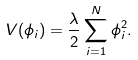<formula> <loc_0><loc_0><loc_500><loc_500>V ( \phi _ { i } ) = \frac { \lambda } { 2 } \sum _ { i = 1 } ^ { N } \phi _ { i } ^ { 2 } .</formula> 